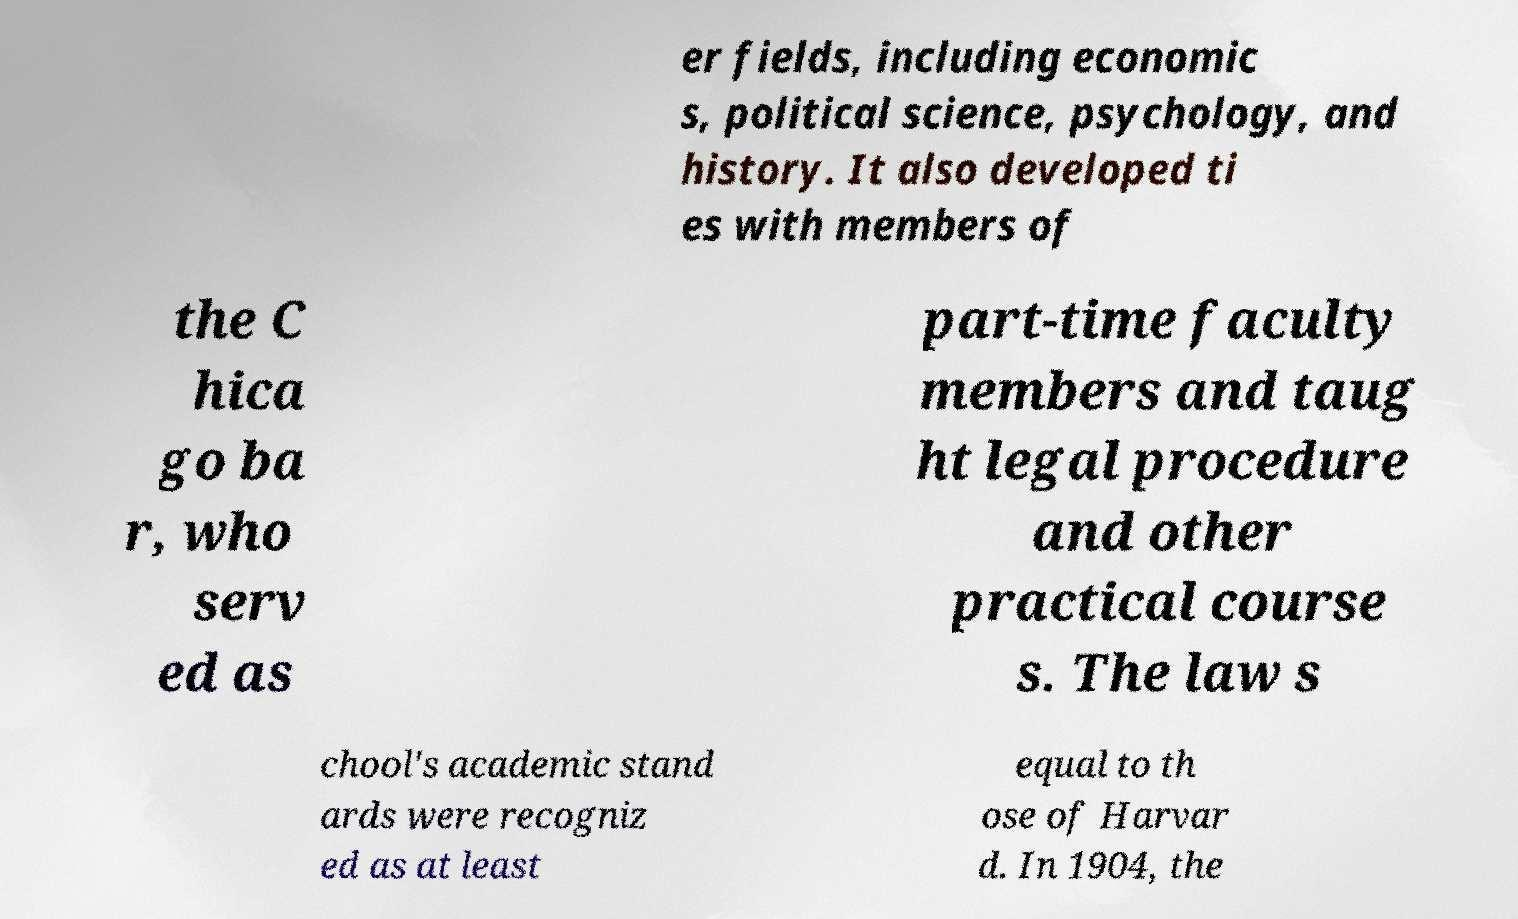I need the written content from this picture converted into text. Can you do that? er fields, including economic s, political science, psychology, and history. It also developed ti es with members of the C hica go ba r, who serv ed as part-time faculty members and taug ht legal procedure and other practical course s. The law s chool's academic stand ards were recogniz ed as at least equal to th ose of Harvar d. In 1904, the 